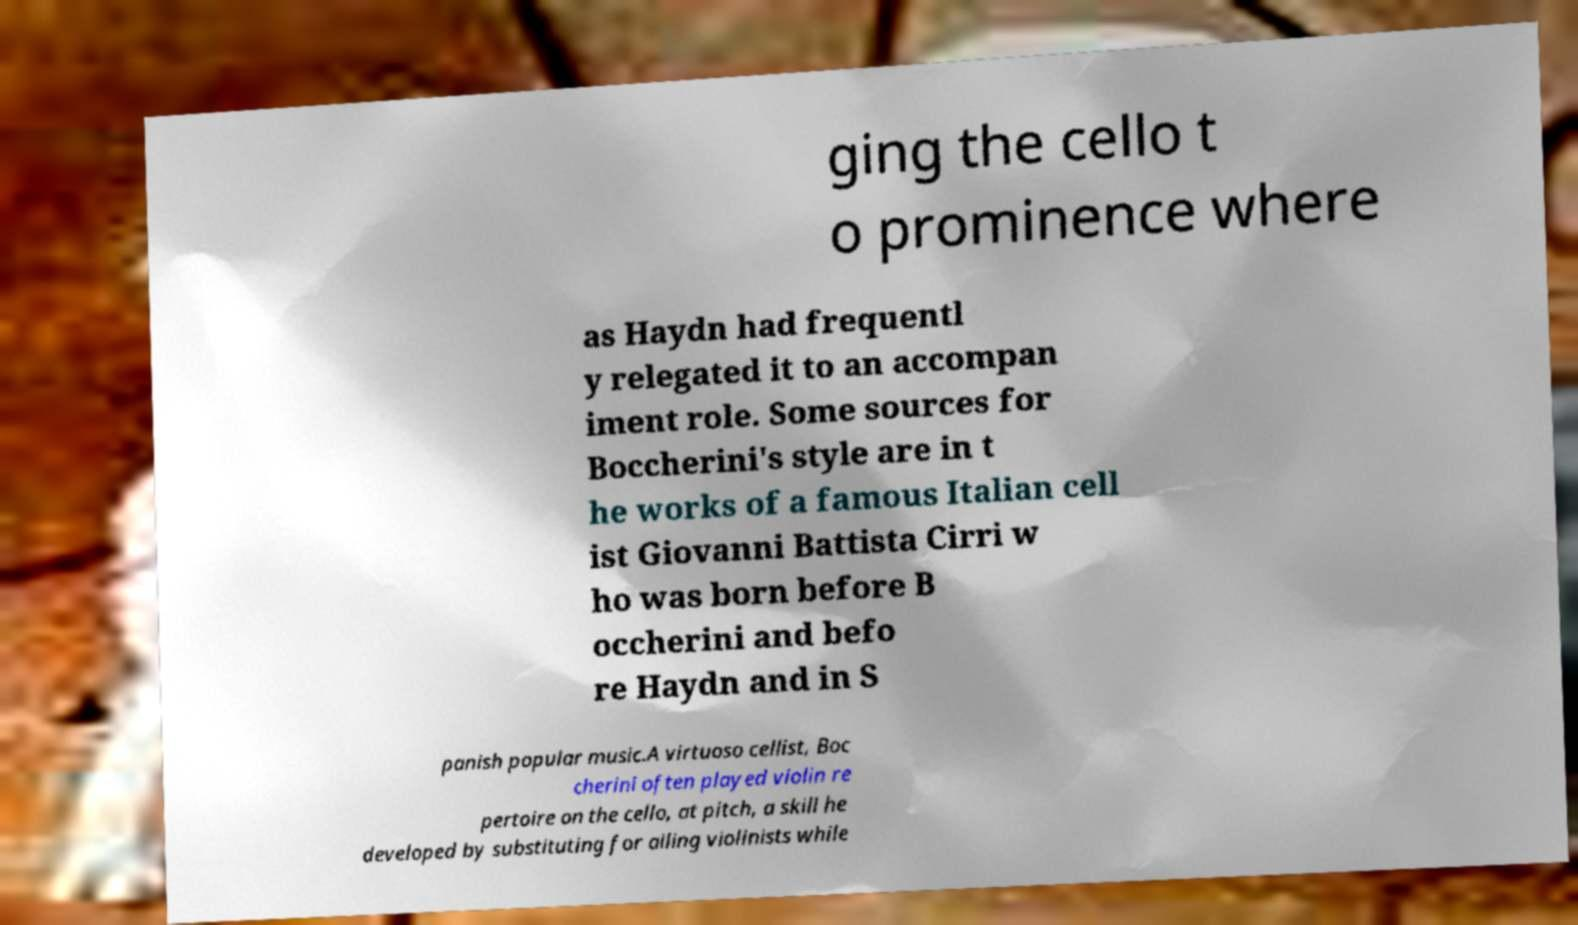I need the written content from this picture converted into text. Can you do that? ging the cello t o prominence where as Haydn had frequentl y relegated it to an accompan iment role. Some sources for Boccherini's style are in t he works of a famous Italian cell ist Giovanni Battista Cirri w ho was born before B occherini and befo re Haydn and in S panish popular music.A virtuoso cellist, Boc cherini often played violin re pertoire on the cello, at pitch, a skill he developed by substituting for ailing violinists while 